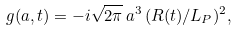<formula> <loc_0><loc_0><loc_500><loc_500>g ( a , t ) = - i \sqrt { 2 \pi } \, a ^ { 3 } \, ( R ( t ) / L _ { P } ) ^ { 2 } ,</formula> 